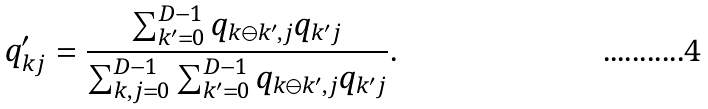Convert formula to latex. <formula><loc_0><loc_0><loc_500><loc_500>q ^ { \prime } _ { k j } = \frac { \sum _ { k ^ { \prime } = 0 } ^ { D - 1 } q _ { k \ominus k ^ { \prime } , j } q _ { k ^ { \prime } j } } { \sum _ { k , j = 0 } ^ { D - 1 } \sum _ { k ^ { \prime } = 0 } ^ { D - 1 } q _ { k \ominus k ^ { \prime } , j } q _ { k ^ { \prime } j } } .</formula> 